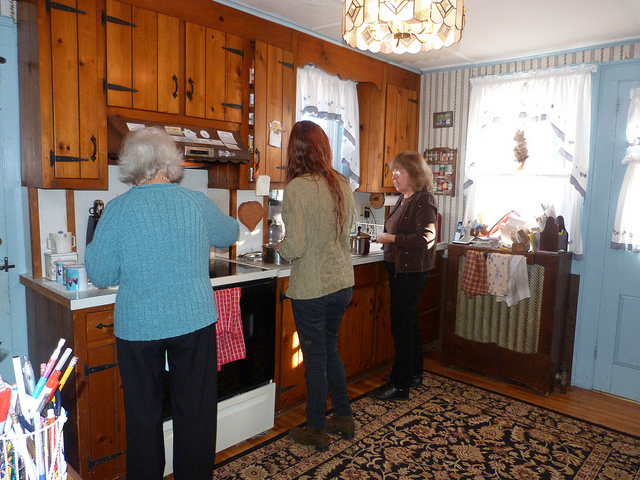What are the people in the photo doing? The person on the left is washing dishes by hand, indicating a homey, perhaps traditional environment that lacks a dishwasher. The person in the center appears to be either cooking or preparing food, while the person on the right stands by, perhaps having a conversation or waiting for something to finish cooking. 